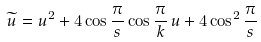Convert formula to latex. <formula><loc_0><loc_0><loc_500><loc_500>\widetilde { u } = u ^ { 2 } + 4 \cos { \frac { \pi } { s } } \cos { \frac { \pi } { k } } \, u + 4 \cos ^ { 2 } { \frac { \pi } { s } }</formula> 